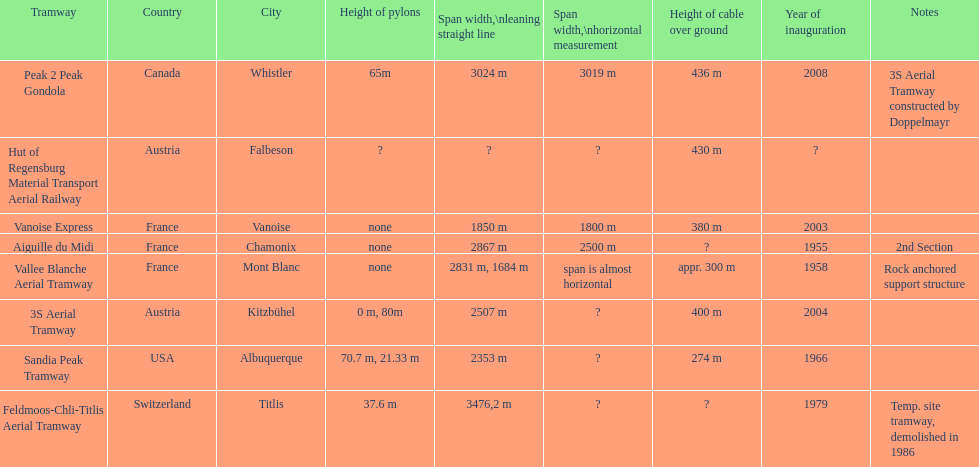How much greater is the height of cable over ground measurement for the peak 2 peak gondola when compared with that of the vanoise express? 56 m. 